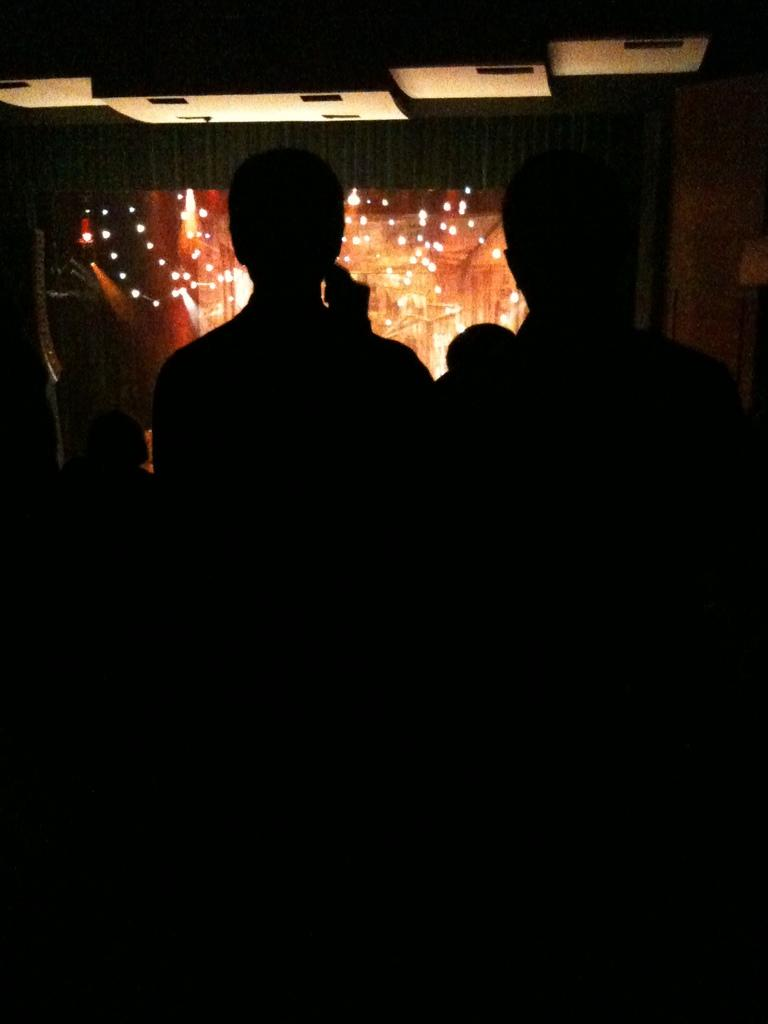Who or what is present in the image? There are people in the image. What can be seen in the background of the image? There are lights visible in the background of the image. What type of apparel is the farmer wearing in the image? There is no farmer present in the image, and therefore no apparel can be described. 